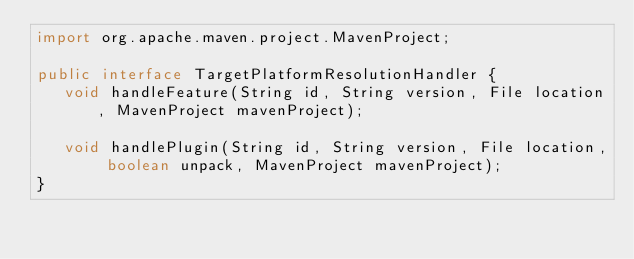Convert code to text. <code><loc_0><loc_0><loc_500><loc_500><_Java_>import org.apache.maven.project.MavenProject;

public interface TargetPlatformResolutionHandler {
   void handleFeature(String id, String version, File location, MavenProject mavenProject);

   void handlePlugin(String id, String version, File location, boolean unpack, MavenProject mavenProject);
}
</code> 